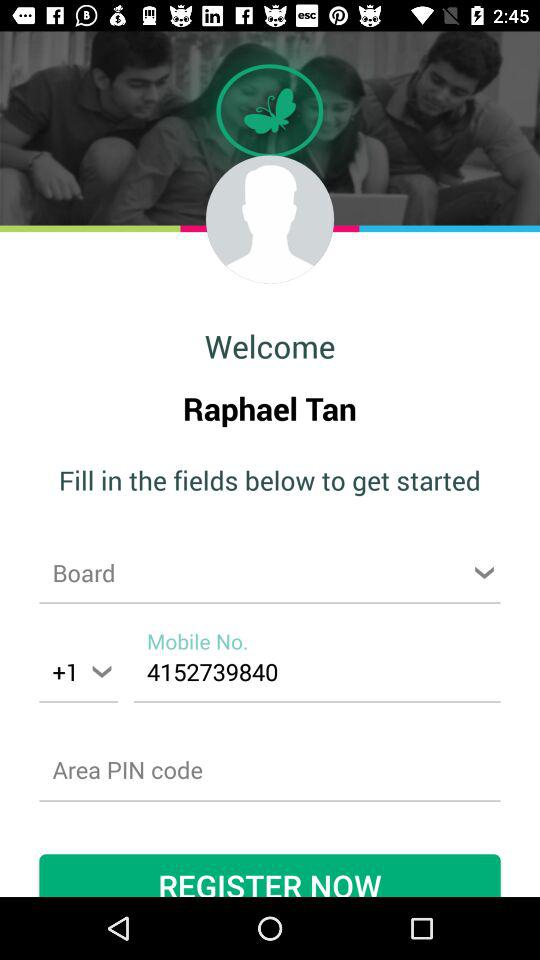What is the phone number? The phone number is +1 4152739840. 